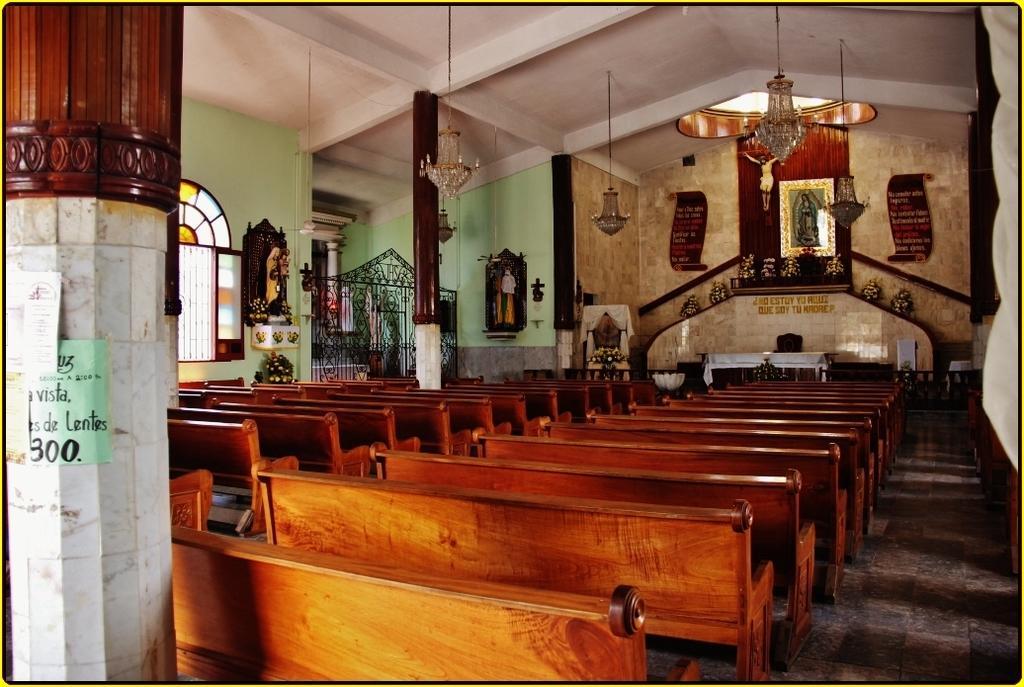In one or two sentences, can you explain what this image depicts? As we can see in the image there is a wall, chandeliers, window, benches and a statue. 